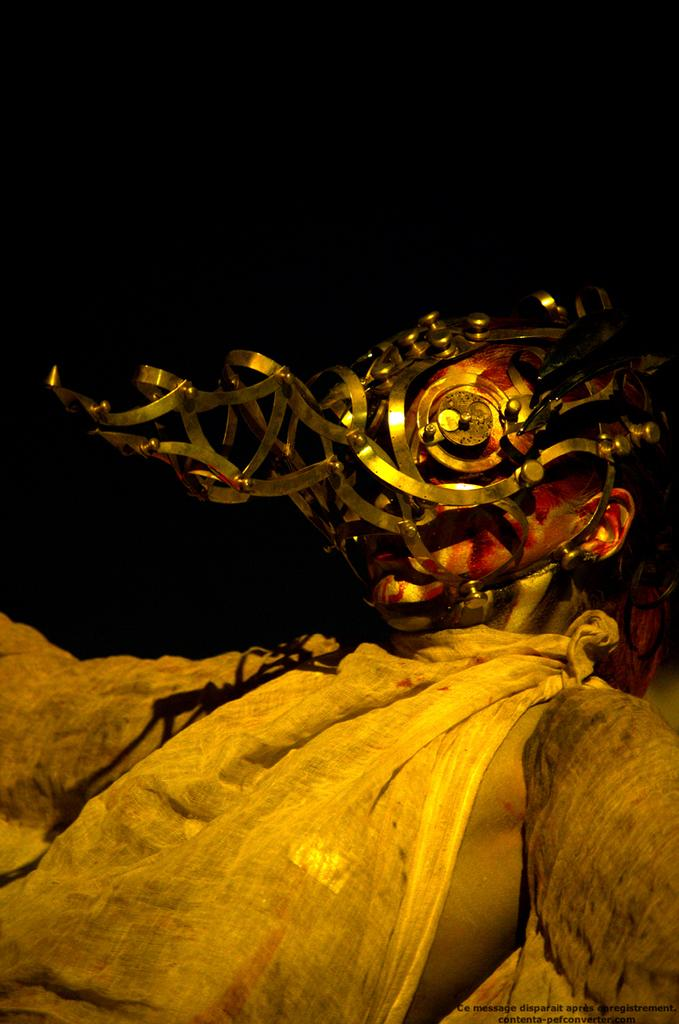Who or what is present in the image? There is a person in the image. What is the person wearing on their face? The person is wearing a mask on their face. What type of division is being performed by the person in the image? There is no indication of any division being performed in the image; the person is simply wearing a mask on their face. 